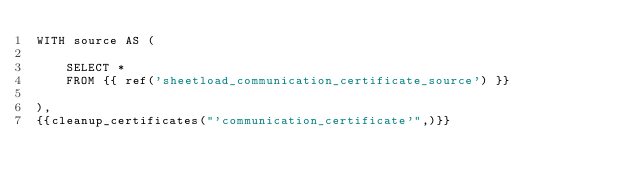Convert code to text. <code><loc_0><loc_0><loc_500><loc_500><_SQL_>WITH source AS (

    SELECT *
    FROM {{ ref('sheetload_communication_certificate_source') }}

),
{{cleanup_certificates("'communication_certificate'",)}}
</code> 